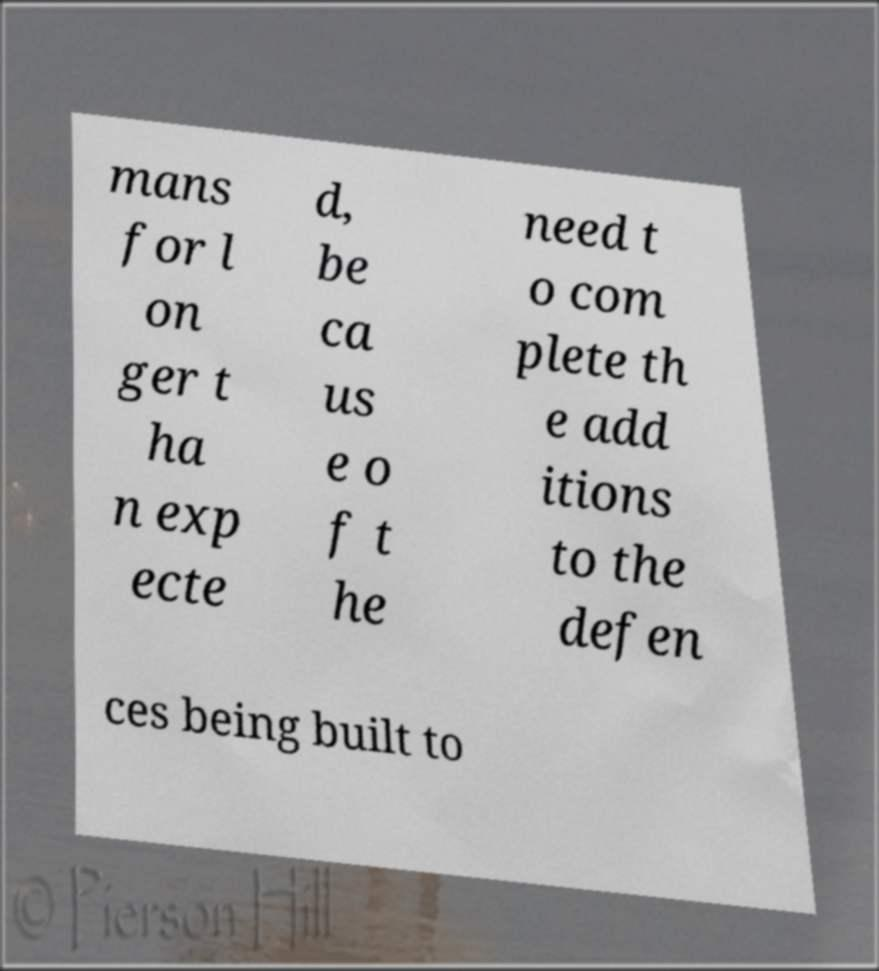Could you assist in decoding the text presented in this image and type it out clearly? mans for l on ger t ha n exp ecte d, be ca us e o f t he need t o com plete th e add itions to the defen ces being built to 